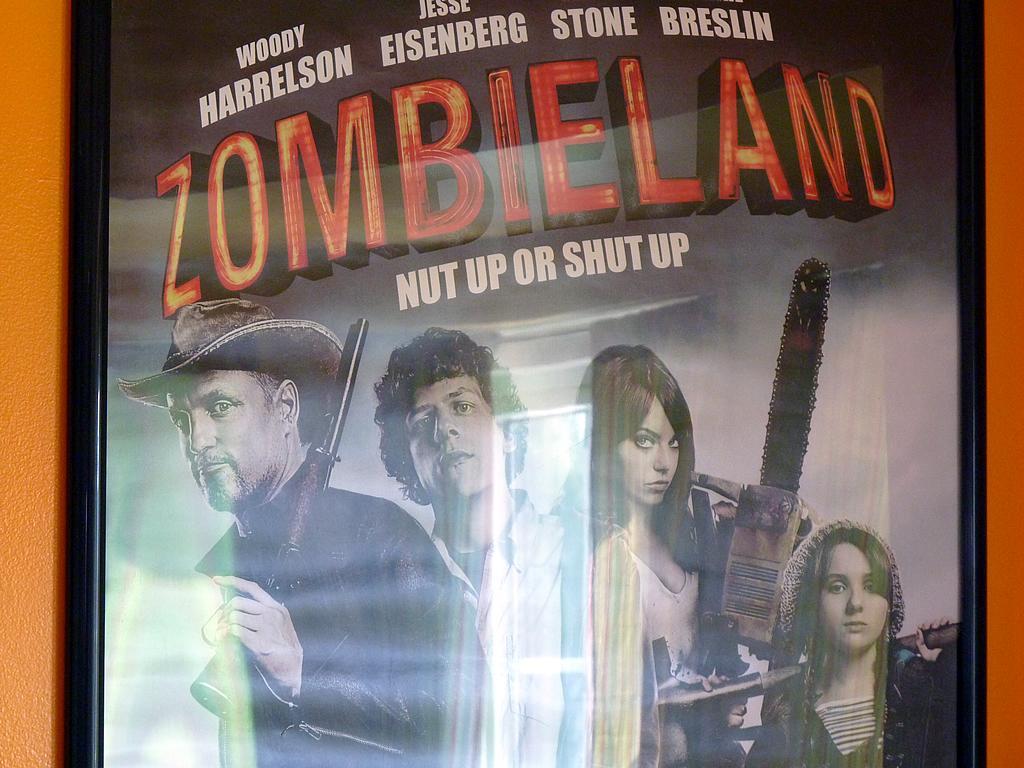How would you summarize this image in a sentence or two? In this image we can see one board with text and images attached to the wall. 